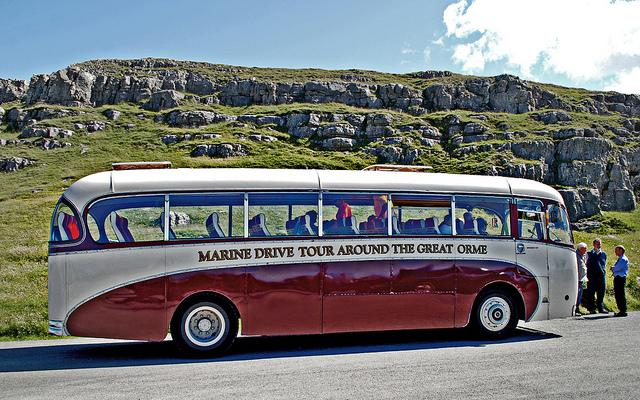What is the bus primarily used for? Please explain your reasoning. tours. The bus is used for tours around the city. 